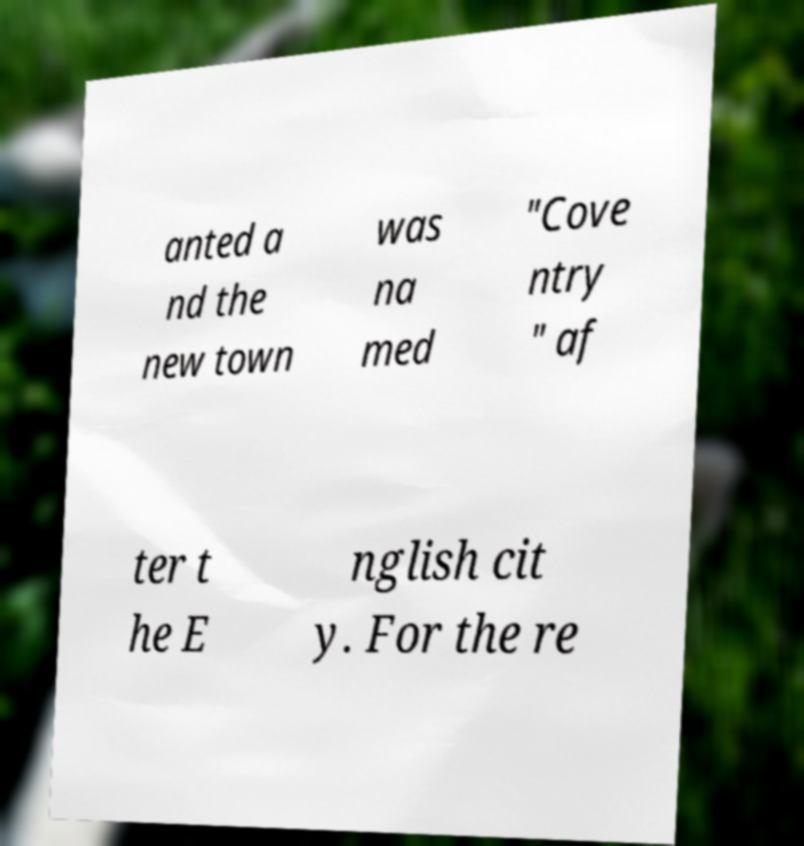Could you assist in decoding the text presented in this image and type it out clearly? anted a nd the new town was na med "Cove ntry " af ter t he E nglish cit y. For the re 